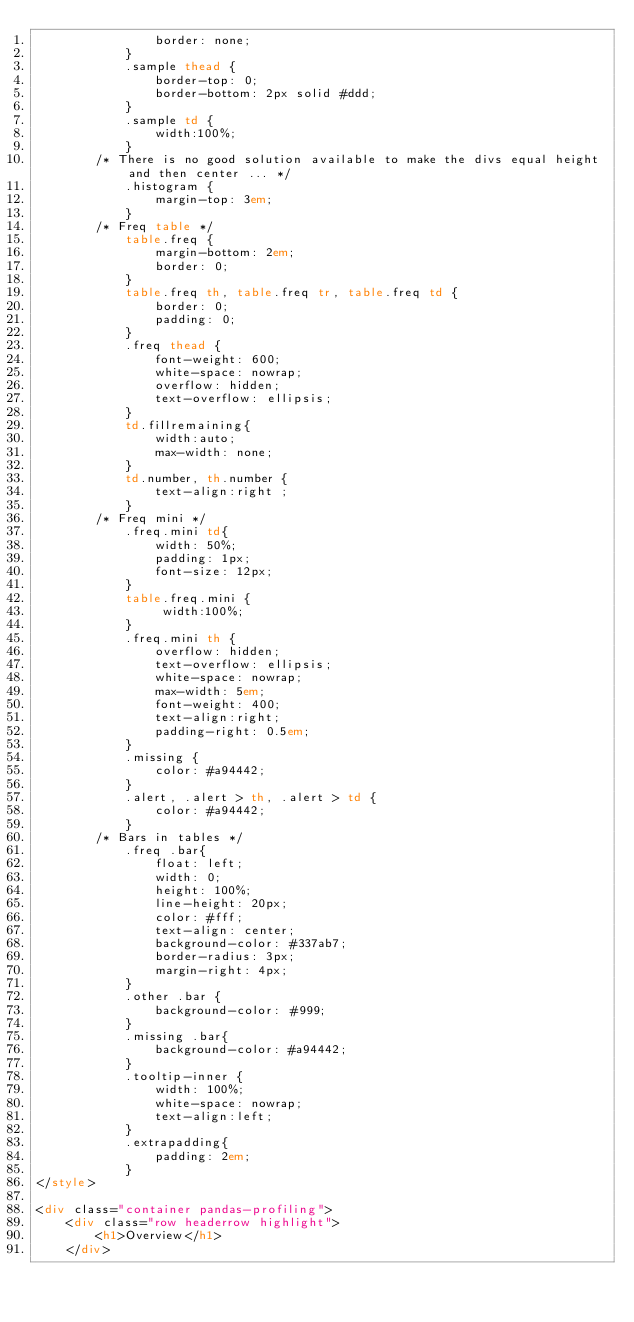Convert code to text. <code><loc_0><loc_0><loc_500><loc_500><_HTML_>                border: none;
            }
            .sample thead {
                border-top: 0;
                border-bottom: 2px solid #ddd;
            }
            .sample td {
                width:100%;
            }
        /* There is no good solution available to make the divs equal height and then center ... */
            .histogram {
                margin-top: 3em;
            }
        /* Freq table */
            table.freq {
                margin-bottom: 2em;
                border: 0;
            }
            table.freq th, table.freq tr, table.freq td {
                border: 0;
                padding: 0;
            }
            .freq thead {
                font-weight: 600;
                white-space: nowrap;
                overflow: hidden;
                text-overflow: ellipsis;
            }
            td.fillremaining{
                width:auto;
                max-width: none;
            }
            td.number, th.number {
                text-align:right ;
            }
        /* Freq mini */
            .freq.mini td{
                width: 50%;
                padding: 1px;
                font-size: 12px;
            }
            table.freq.mini {
                 width:100%;
            }
            .freq.mini th {
                overflow: hidden;
                text-overflow: ellipsis;
                white-space: nowrap;
                max-width: 5em;
                font-weight: 400;
                text-align:right;
                padding-right: 0.5em;
            }
            .missing {
                color: #a94442;
            }
            .alert, .alert > th, .alert > td {
                color: #a94442;
            }
        /* Bars in tables */
            .freq .bar{
                float: left;
                width: 0;
                height: 100%;
                line-height: 20px;
                color: #fff;
                text-align: center;
                background-color: #337ab7;
                border-radius: 3px;
                margin-right: 4px;
            }
            .other .bar {
                background-color: #999;
            }
            .missing .bar{
                background-color: #a94442;
            }
            .tooltip-inner {
                width: 100%;
                white-space: nowrap;
                text-align:left;
            }
            .extrapadding{
                padding: 2em;
            }
</style>

<div class="container pandas-profiling">
    <div class="row headerrow highlight">
        <h1>Overview</h1>
    </div></code> 